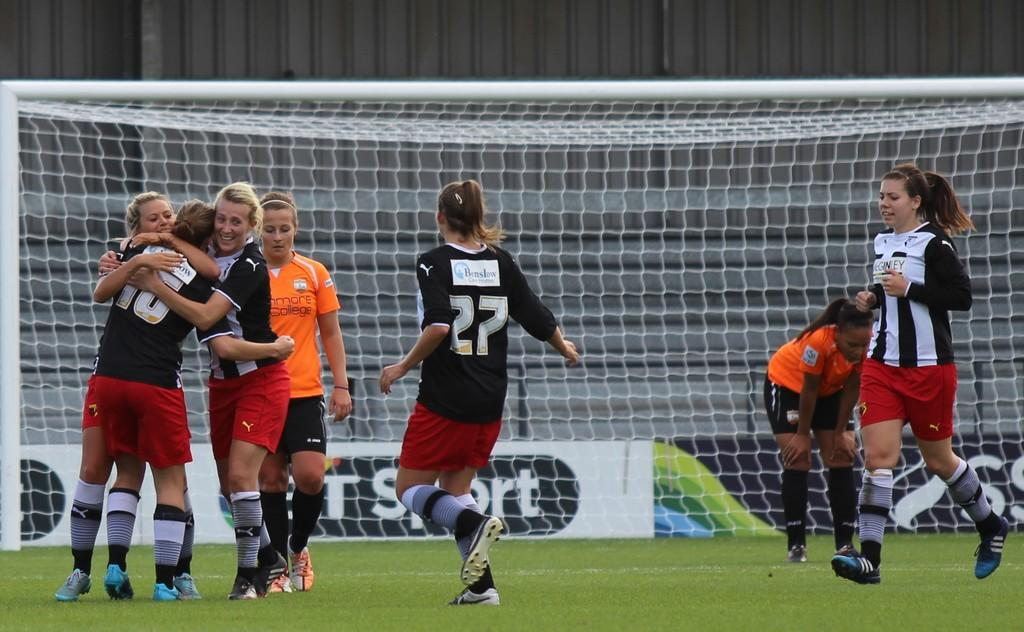<image>
Render a clear and concise summary of the photo. Soccer players are on a field and one of them has the number 27 on her jersey. 